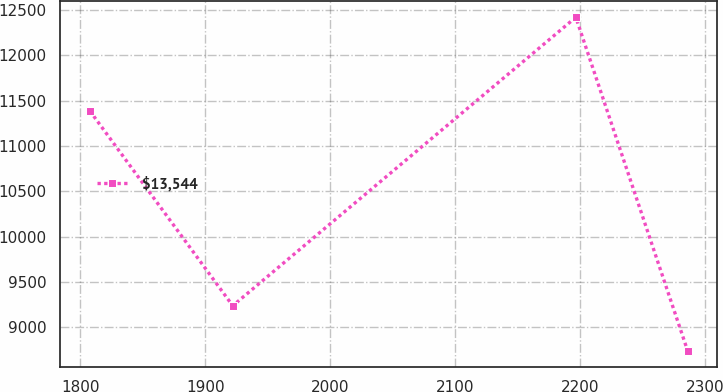Convert chart to OTSL. <chart><loc_0><loc_0><loc_500><loc_500><line_chart><ecel><fcel>$13,544<nl><fcel>1807.72<fcel>11387.9<nl><fcel>1922.08<fcel>9238.67<nl><fcel>2196.59<fcel>12419.8<nl><fcel>2285.99<fcel>8744.12<nl></chart> 